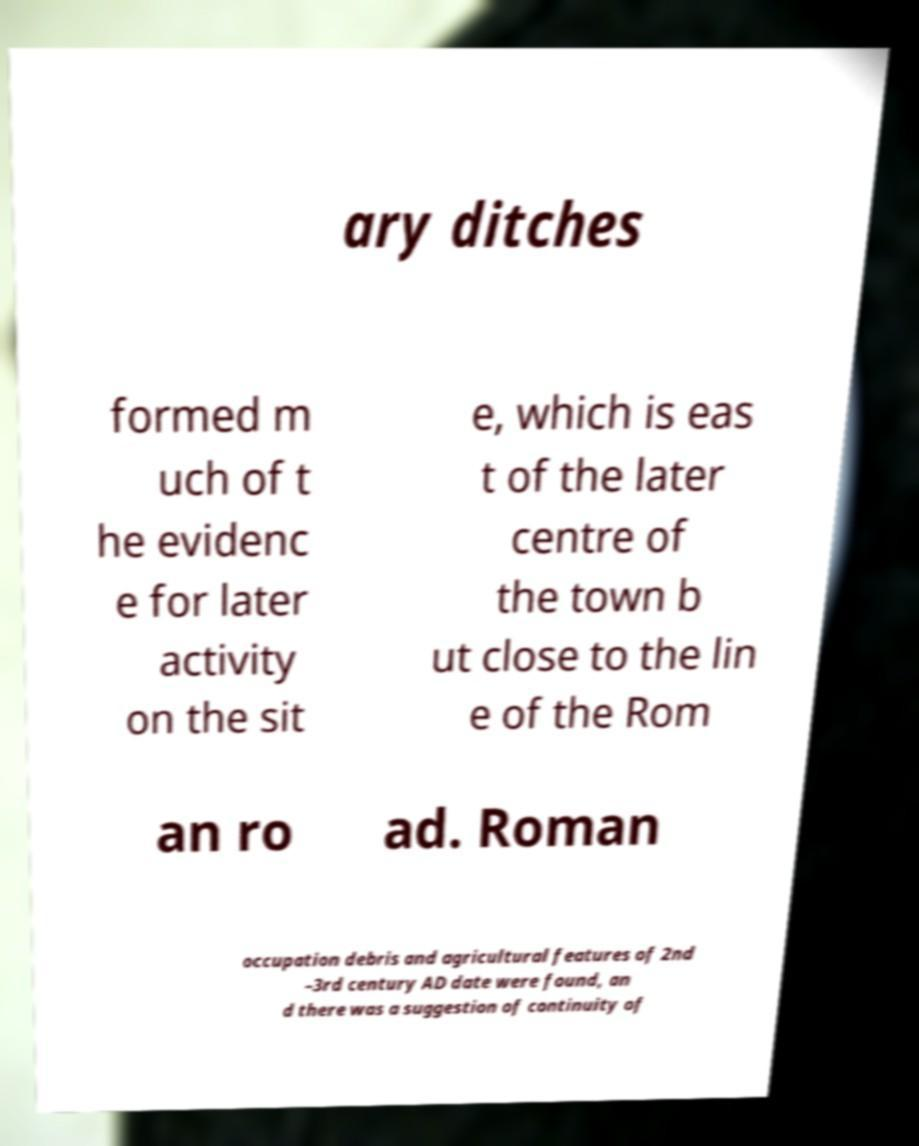Could you assist in decoding the text presented in this image and type it out clearly? ary ditches formed m uch of t he evidenc e for later activity on the sit e, which is eas t of the later centre of the town b ut close to the lin e of the Rom an ro ad. Roman occupation debris and agricultural features of 2nd –3rd century AD date were found, an d there was a suggestion of continuity of 